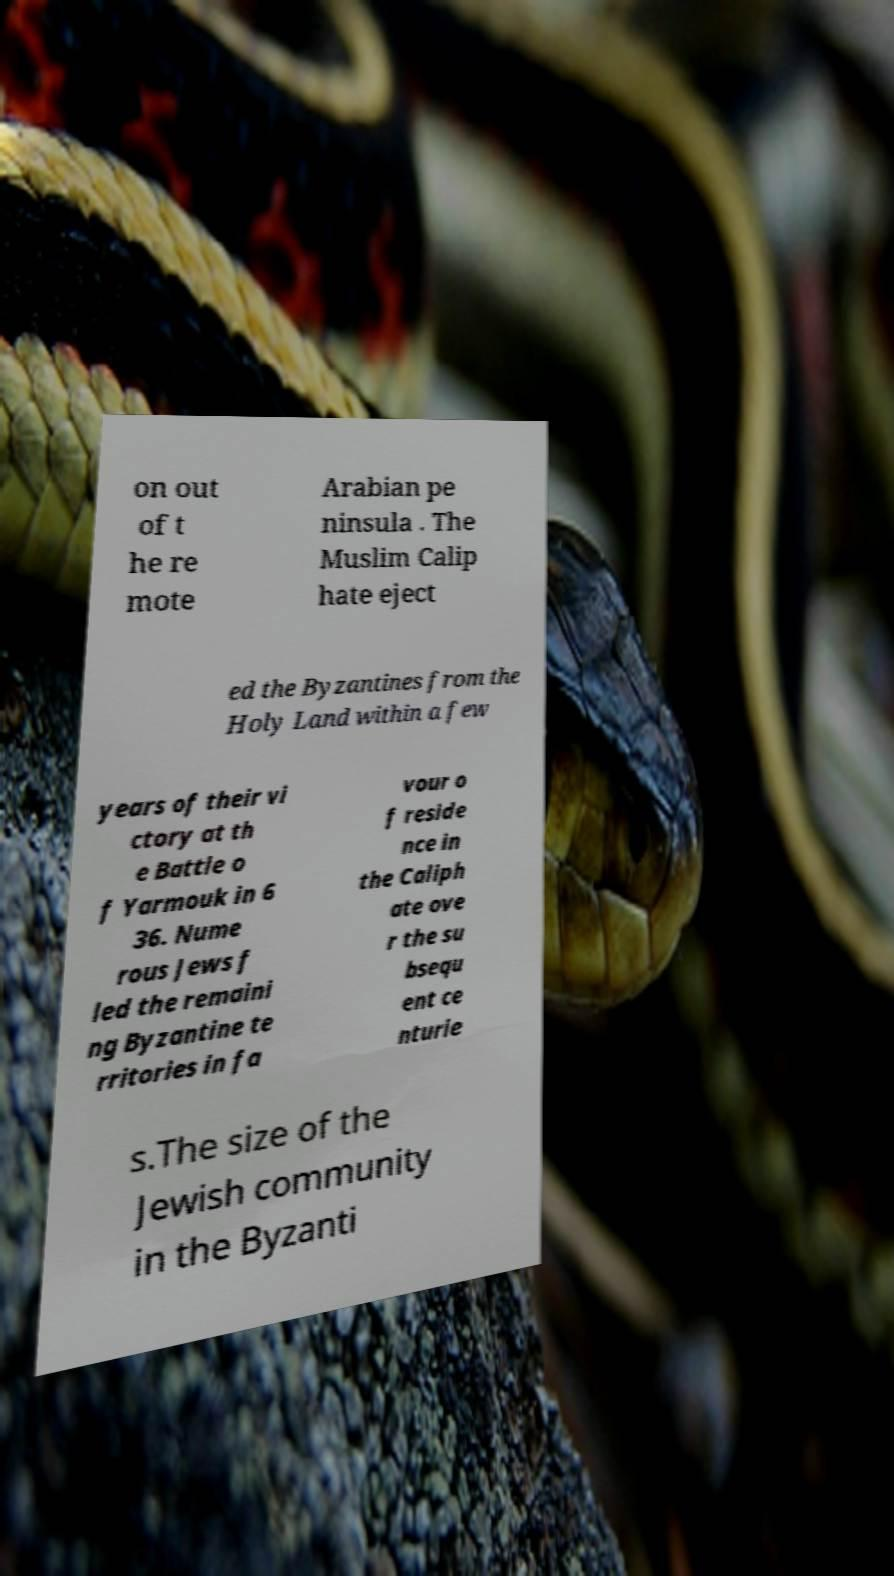Please identify and transcribe the text found in this image. on out of t he re mote Arabian pe ninsula . The Muslim Calip hate eject ed the Byzantines from the Holy Land within a few years of their vi ctory at th e Battle o f Yarmouk in 6 36. Nume rous Jews f led the remaini ng Byzantine te rritories in fa vour o f reside nce in the Caliph ate ove r the su bsequ ent ce nturie s.The size of the Jewish community in the Byzanti 